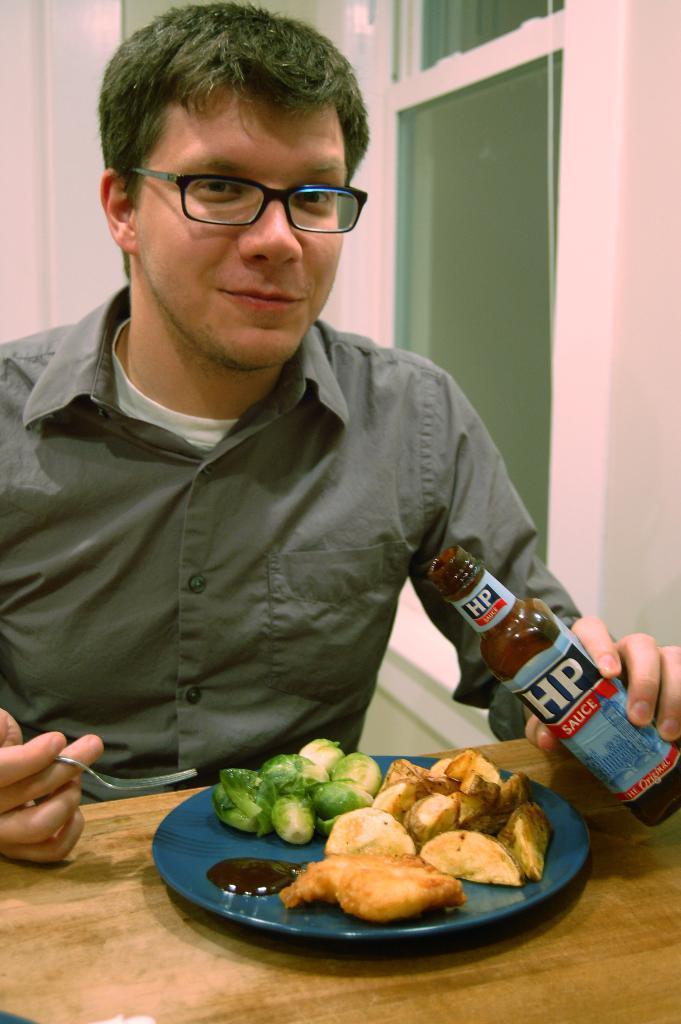Could you give a brief overview of what you see in this image? In this image I see a man who is wearing a shirt and I see a table over here on which there is a blue plate on which there is food and I see he is holding a spoon in one hand and a bottle in other hand and I see stickers on the bottle on which there is something written. In the background I see the wall which is of pink in color and I see the window over here. 